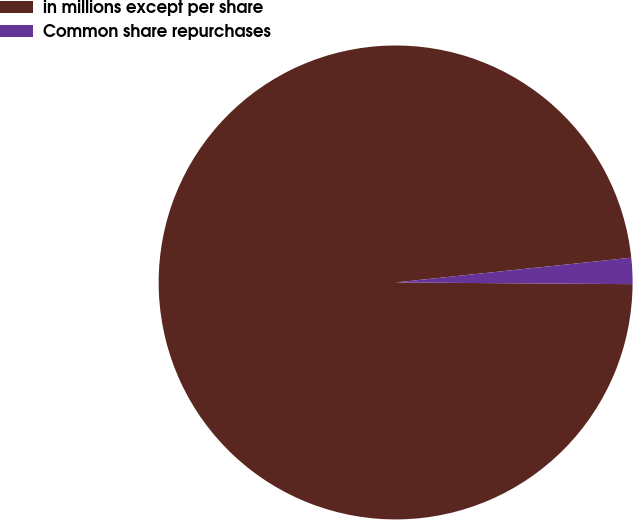Convert chart to OTSL. <chart><loc_0><loc_0><loc_500><loc_500><pie_chart><fcel>in millions except per share<fcel>Common share repurchases<nl><fcel>98.22%<fcel>1.78%<nl></chart> 